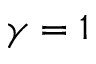<formula> <loc_0><loc_0><loc_500><loc_500>\gamma = 1</formula> 